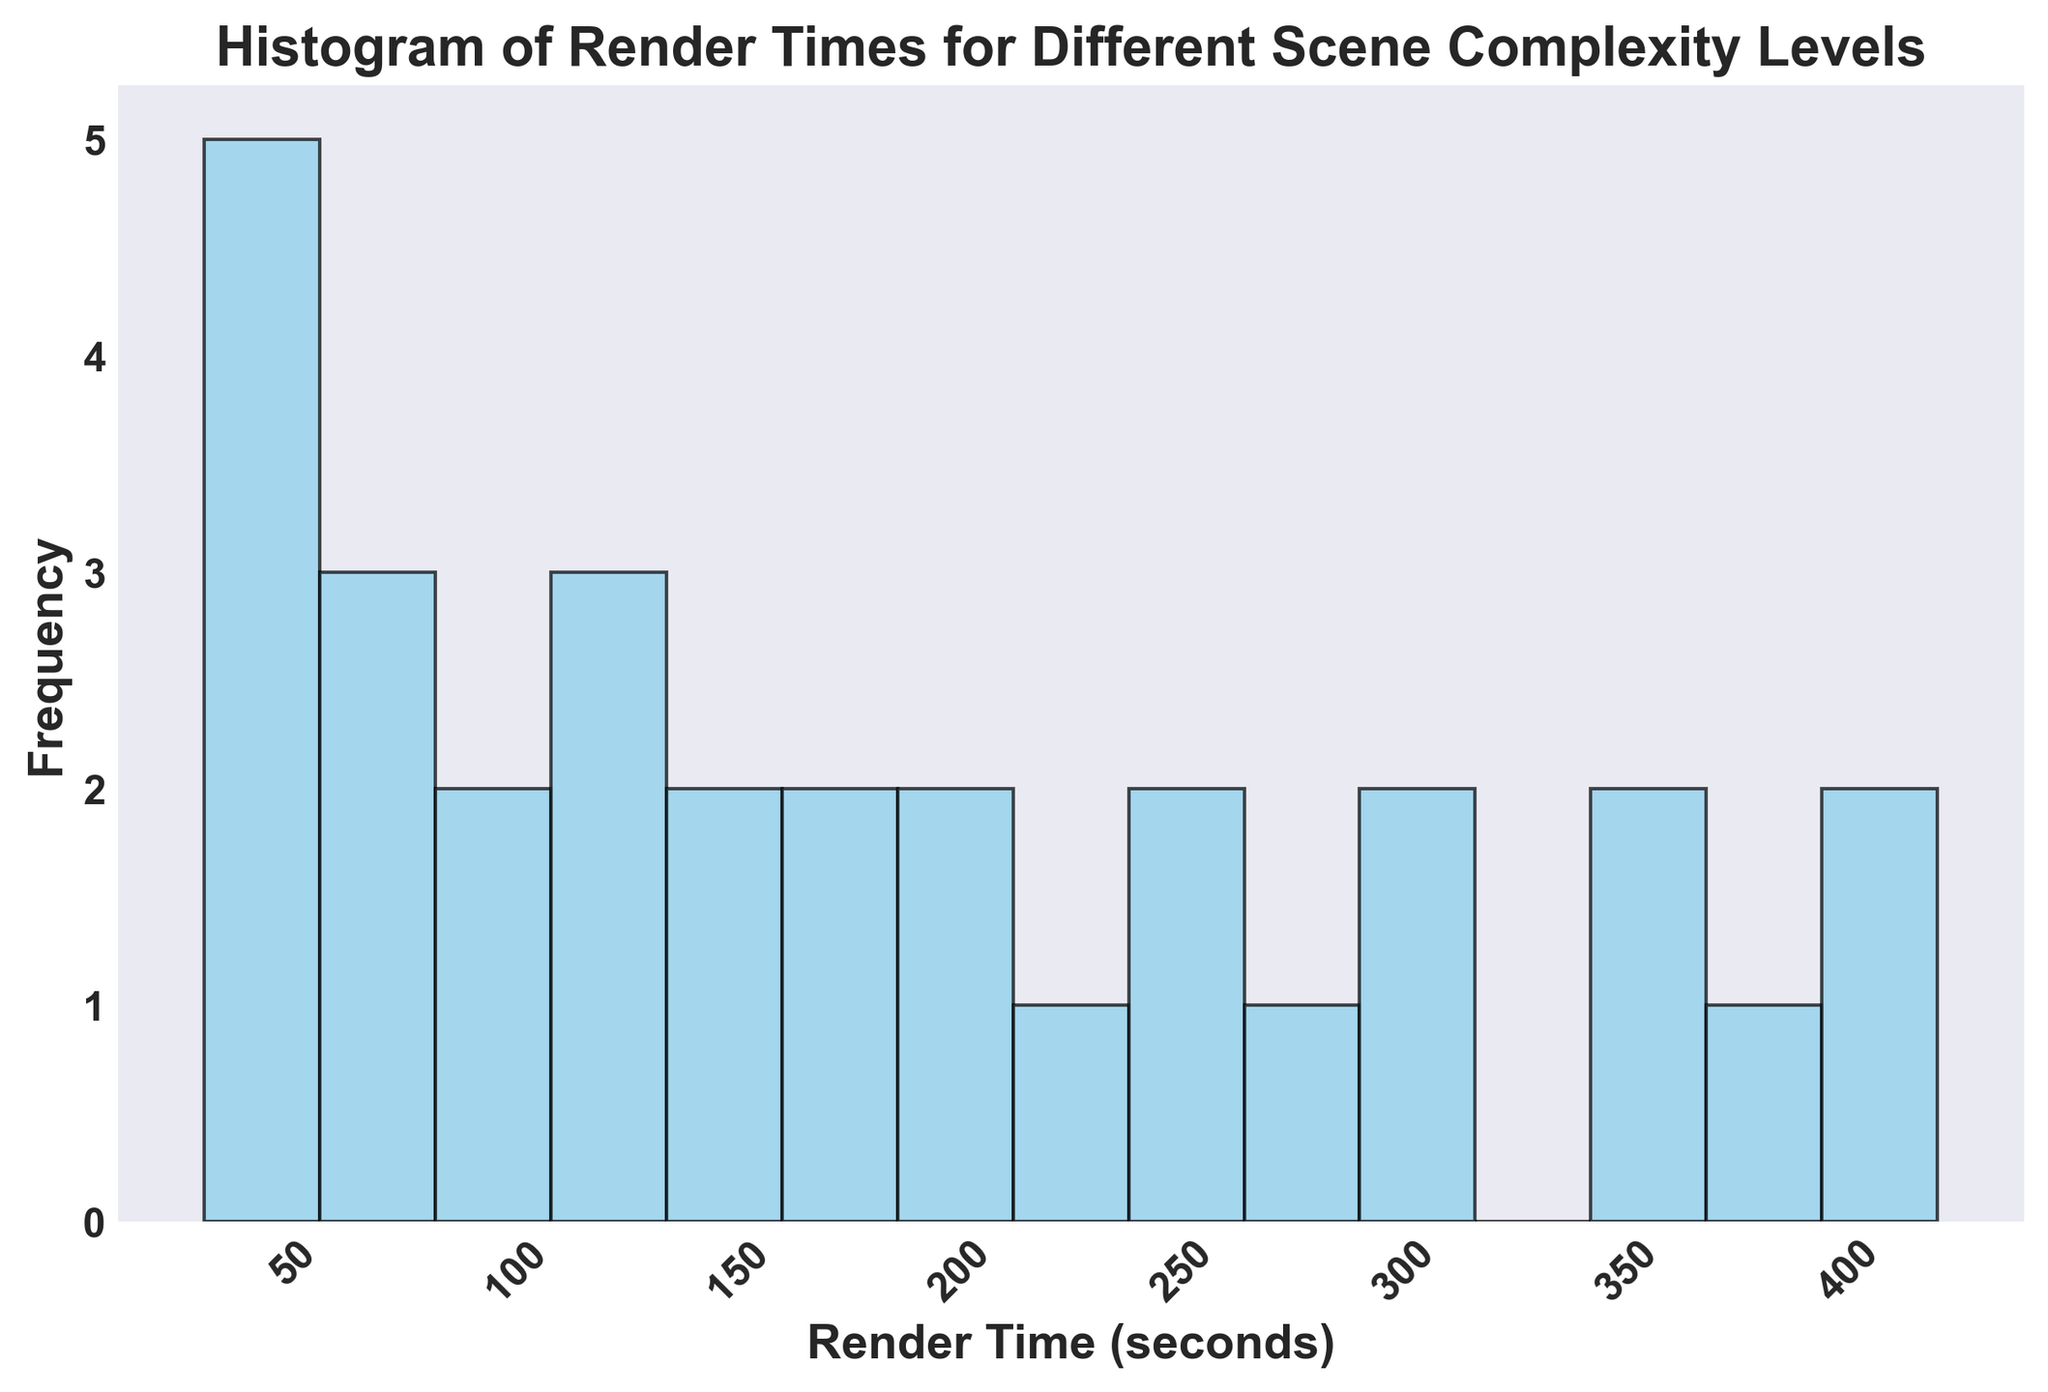What is the frequency of render times in the range between 300 and 350 seconds? Count the number of occurrences of render times between 300 and 350 seconds by examining the heights of the bars in that range. The render times in this range appear 3 times: for 310, 290, and 280 seconds.
Answer: 3 Between which ranges of render times can you find the highest frequency? Identify the bar with the maximum height, then look at the x-axis to determine the range it represents. The highest frequency is found in the range of around 40 to 60 seconds.
Answer: 40-60 seconds How does the frequency of render times between 100 and 200 seconds compare to the frequency of render times between 300 and 400 seconds? Count the number of occurrences between 100-200 seconds and compare them to the number of occurrences between 300-400 seconds. 100-200 seconds have a higher frequency as there are various bars in that range compared to the fewer bars in the 300-400 seconds range.
Answer: 100-200 seconds has a higher frequency What is the approximate median render time visible in the histogram? To determine the median render time, find the middle value of the sorted render times. Because there are 30 total values, the median would be the average of the 15th and 16th values. These values are around the central bins in the histogram (approximately 200 seconds).
Answer: 200 seconds What can you infer about the distribution shape of the render times from the histogram? Observing the histogram, the render times are not symmetrically distributed, showing a positive skew (right-skewed) where higher render times have less frequency and lower render times have higher frequency.
Answer: Positively skewed (right-skewed) Which range of render times has the lowest frequency? Look at the bar with the smallest height and identify the corresponding range on the x-axis. The lowest frequency can be seen in the range of around 30 to 40 seconds and some higher ranges like between 360 and 420 seconds.
Answer: 30-40 seconds Are there any render times recorded between 0 and 50 seconds? Check if there are any bars present within the 0 to 50 seconds range on the x-axis. There are several bars, indicating frequencies within that range.
Answer: Yes 